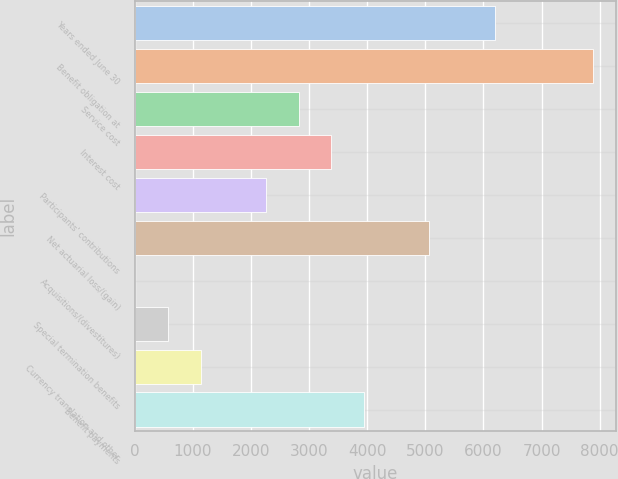Convert chart. <chart><loc_0><loc_0><loc_500><loc_500><bar_chart><fcel>Years ended June 30<fcel>Benefit obligation at<fcel>Service cost<fcel>Interest cost<fcel>Participants' contributions<fcel>Net actuarial loss/(gain)<fcel>Acquisitions/(divestitures)<fcel>Special termination benefits<fcel>Currency translation and other<fcel>Benefit payments<nl><fcel>6194.5<fcel>7882<fcel>2819.5<fcel>3382<fcel>2257<fcel>5069.5<fcel>7<fcel>569.5<fcel>1132<fcel>3944.5<nl></chart> 